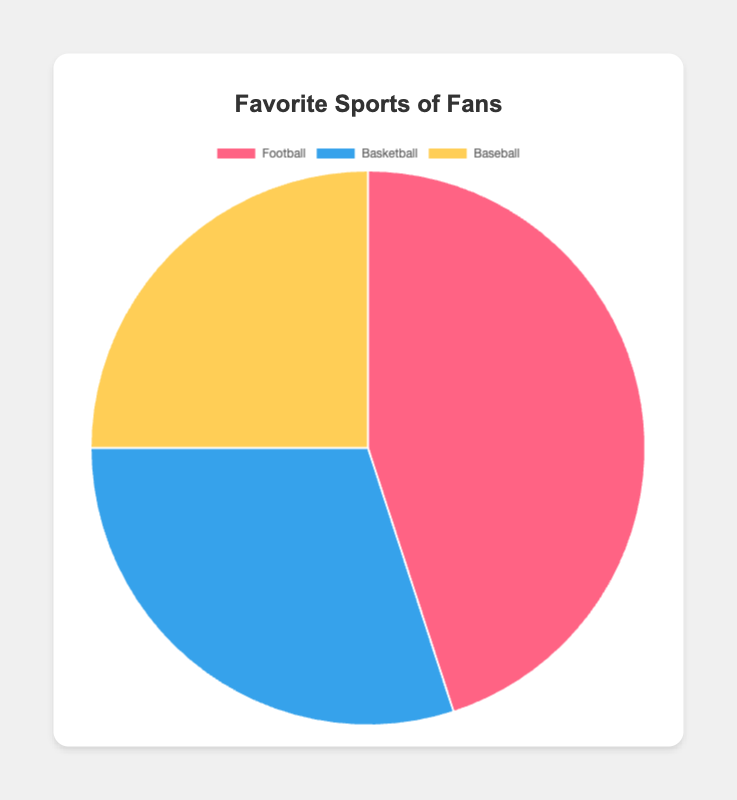Which sport has the highest percentage of fans? To find the sport with the highest percentage, we can compare each sport's percentage. Football has 45%, which is higher than Basketball's 30% and Baseball's 25%.
Answer: Football What is the combined percentage of fans for Basketball and Baseball? We can find the combined percentage by adding the percentages of Basketball and Baseball. Basketball has 30% and Baseball has 25%. So, 30% + 25% = 55%.
Answer: 55% How much more popular is Football than Baseball? To find out how much more popular Football is than Baseball, we subtract Baseball's percentage from Football's. Football has 45% and Baseball has 25%. So, 45% - 25% = 20%.
Answer: 20% Which sport is the least popular? By comparing the percentages, we can see that Baseball has the lowest percentage at 25%. Football has 45% and Basketball has 30%, which are both higher.
Answer: Baseball What is the difference in fan percentage between Football and Basketball? To find the difference, we subtract Basketball's percentage from Football's. Football has 45% and Basketball has 30%. So, 45% - 30% = 15%.
Answer: 15% What proportion of the total fan base prefers Football? To find the proportion, we can use the percentage directly since it represents the part of the whole. For Football, it's 45%.
Answer: 45% If the total number of fans is 1,000, how many fans prefer Baseball? To find this, we use the percentage for Baseball, which is 25%. 25% of 1,000 fans is 0.25 * 1,000 = 250 fans.
Answer: 250 How do the fan percentages for Basketball and Baseball compare visually? Visually, the slice for Basketball (30%) will be larger than Baseball (25%). The colors would help to distinguish the two easily, with Basketball typically rendered in blue and Baseball in yellow in the provided visualization.
Answer: Basketball is larger 